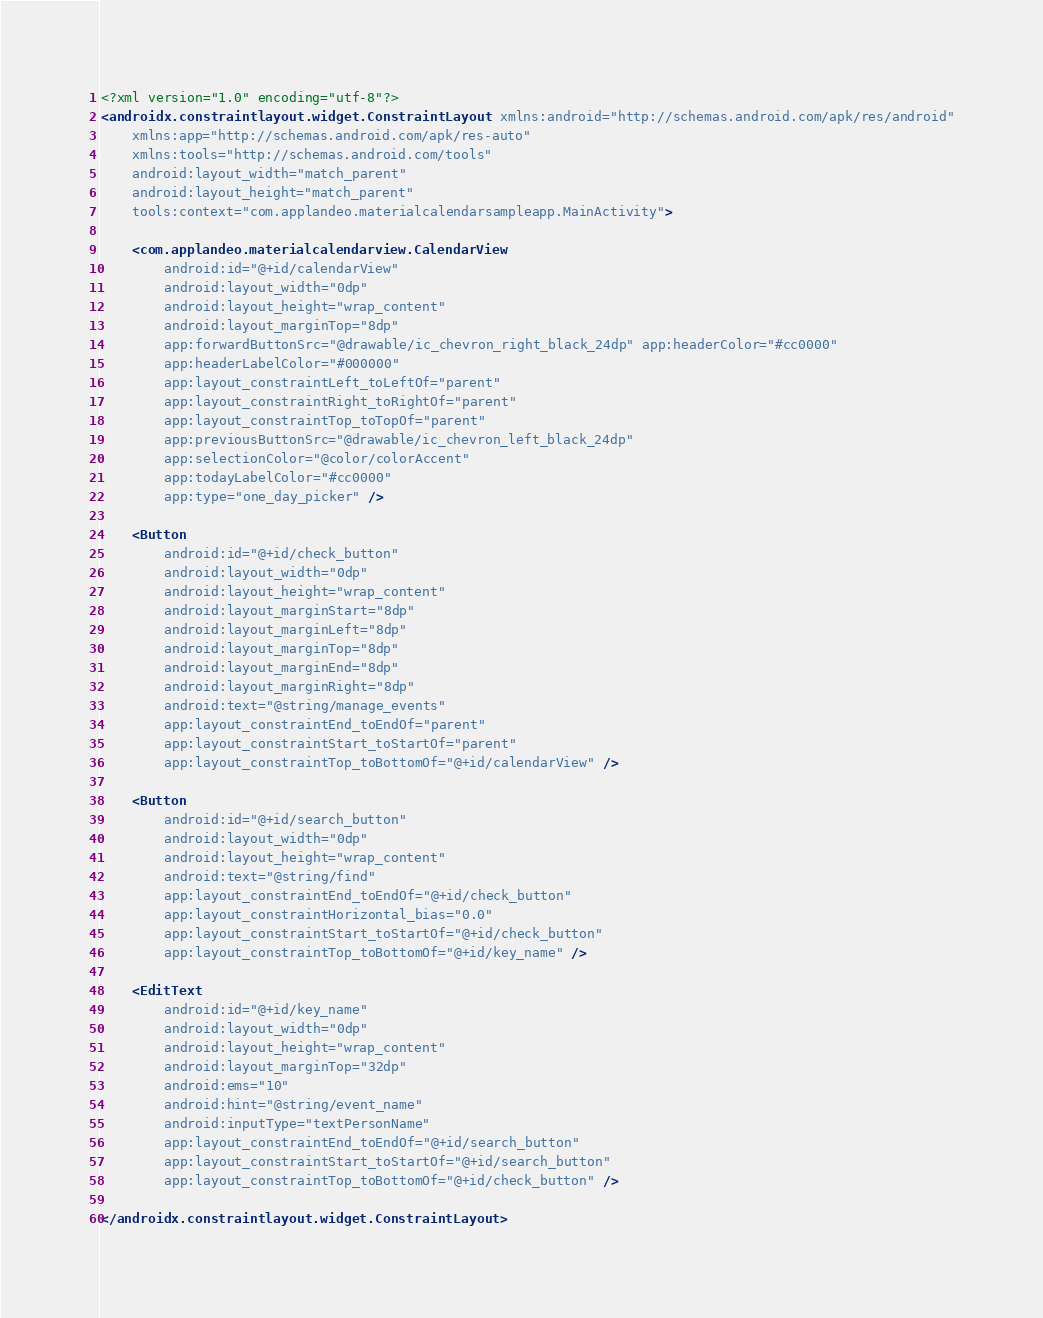<code> <loc_0><loc_0><loc_500><loc_500><_XML_><?xml version="1.0" encoding="utf-8"?>
<androidx.constraintlayout.widget.ConstraintLayout xmlns:android="http://schemas.android.com/apk/res/android"
    xmlns:app="http://schemas.android.com/apk/res-auto"
    xmlns:tools="http://schemas.android.com/tools"
    android:layout_width="match_parent"
    android:layout_height="match_parent"
    tools:context="com.applandeo.materialcalendarsampleapp.MainActivity">

    <com.applandeo.materialcalendarview.CalendarView
        android:id="@+id/calendarView"
        android:layout_width="0dp"
        android:layout_height="wrap_content"
        android:layout_marginTop="8dp"
        app:forwardButtonSrc="@drawable/ic_chevron_right_black_24dp" app:headerColor="#cc0000"
        app:headerLabelColor="#000000"
        app:layout_constraintLeft_toLeftOf="parent"
        app:layout_constraintRight_toRightOf="parent"
        app:layout_constraintTop_toTopOf="parent"
        app:previousButtonSrc="@drawable/ic_chevron_left_black_24dp"
        app:selectionColor="@color/colorAccent"
        app:todayLabelColor="#cc0000"
        app:type="one_day_picker" />

    <Button
        android:id="@+id/check_button"
        android:layout_width="0dp"
        android:layout_height="wrap_content"
        android:layout_marginStart="8dp"
        android:layout_marginLeft="8dp"
        android:layout_marginTop="8dp"
        android:layout_marginEnd="8dp"
        android:layout_marginRight="8dp"
        android:text="@string/manage_events"
        app:layout_constraintEnd_toEndOf="parent"
        app:layout_constraintStart_toStartOf="parent"
        app:layout_constraintTop_toBottomOf="@+id/calendarView" />

    <Button
        android:id="@+id/search_button"
        android:layout_width="0dp"
        android:layout_height="wrap_content"
        android:text="@string/find"
        app:layout_constraintEnd_toEndOf="@+id/check_button"
        app:layout_constraintHorizontal_bias="0.0"
        app:layout_constraintStart_toStartOf="@+id/check_button"
        app:layout_constraintTop_toBottomOf="@+id/key_name" />

    <EditText
        android:id="@+id/key_name"
        android:layout_width="0dp"
        android:layout_height="wrap_content"
        android:layout_marginTop="32dp"
        android:ems="10"
        android:hint="@string/event_name"
        android:inputType="textPersonName"
        app:layout_constraintEnd_toEndOf="@+id/search_button"
        app:layout_constraintStart_toStartOf="@+id/search_button"
        app:layout_constraintTop_toBottomOf="@+id/check_button" />

</androidx.constraintlayout.widget.ConstraintLayout></code> 